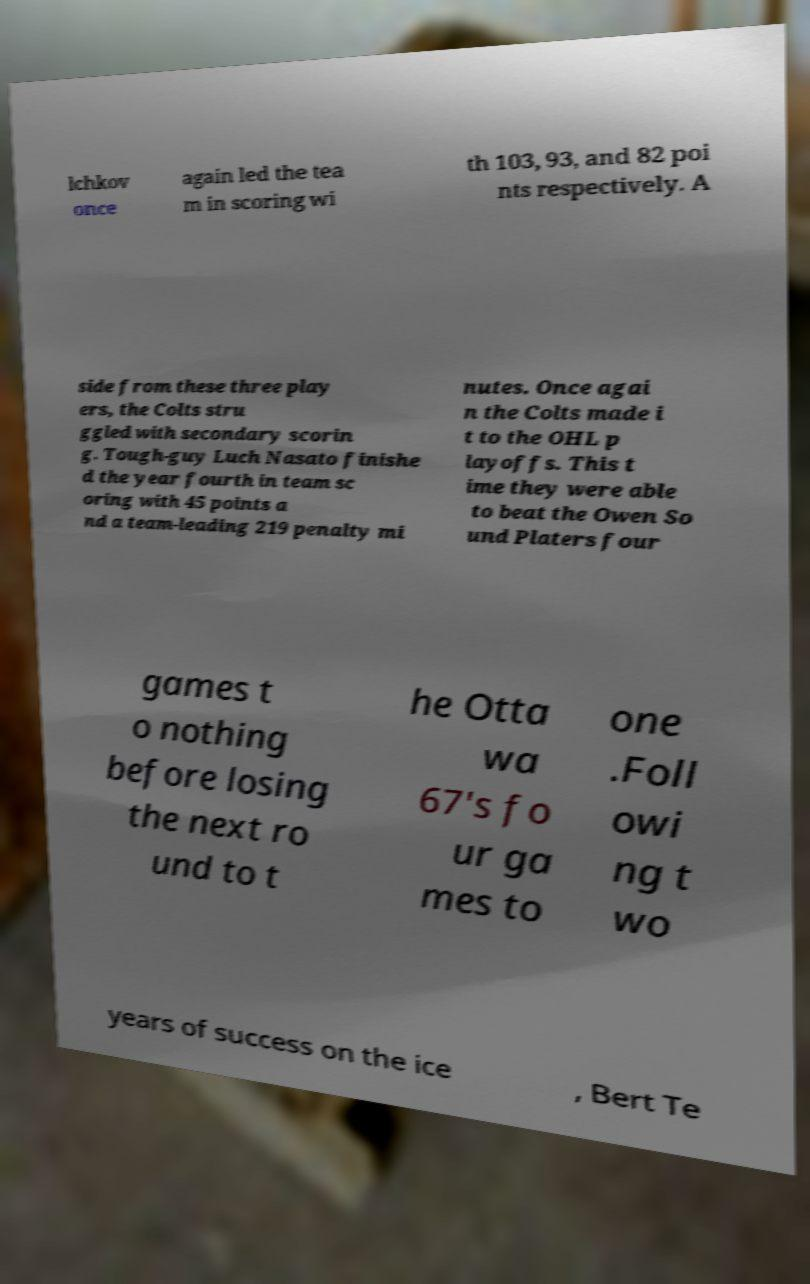Please identify and transcribe the text found in this image. lchkov once again led the tea m in scoring wi th 103, 93, and 82 poi nts respectively. A side from these three play ers, the Colts stru ggled with secondary scorin g. Tough-guy Luch Nasato finishe d the year fourth in team sc oring with 45 points a nd a team-leading 219 penalty mi nutes. Once agai n the Colts made i t to the OHL p layoffs. This t ime they were able to beat the Owen So und Platers four games t o nothing before losing the next ro und to t he Otta wa 67's fo ur ga mes to one .Foll owi ng t wo years of success on the ice , Bert Te 